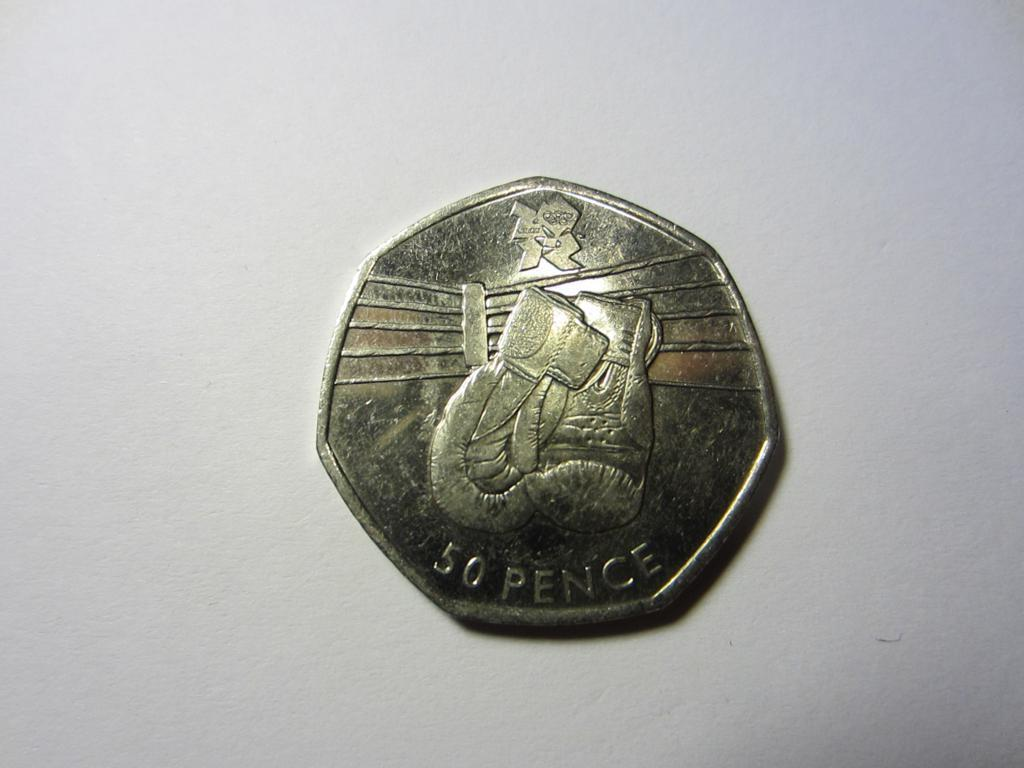<image>
Present a compact description of the photo's key features. A single coin that is worth 50 pence 